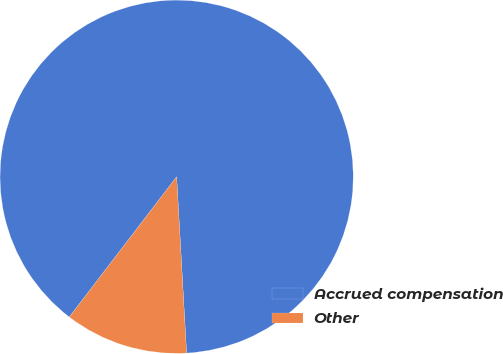Convert chart. <chart><loc_0><loc_0><loc_500><loc_500><pie_chart><fcel>Accrued compensation<fcel>Other<nl><fcel>88.71%<fcel>11.29%<nl></chart> 